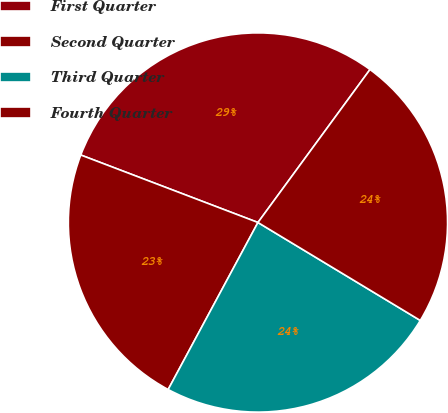Convert chart to OTSL. <chart><loc_0><loc_0><loc_500><loc_500><pie_chart><fcel>First Quarter<fcel>Second Quarter<fcel>Third Quarter<fcel>Fourth Quarter<nl><fcel>29.27%<fcel>22.94%<fcel>24.21%<fcel>23.58%<nl></chart> 